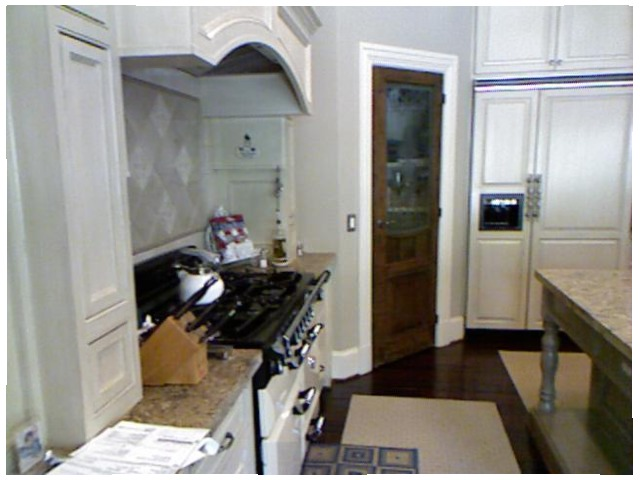<image>
Is there a knife block on the paper? No. The knife block is not positioned on the paper. They may be near each other, but the knife block is not supported by or resting on top of the paper. Is the door to the left of the white door? Yes. From this viewpoint, the door is positioned to the left side relative to the white door. 